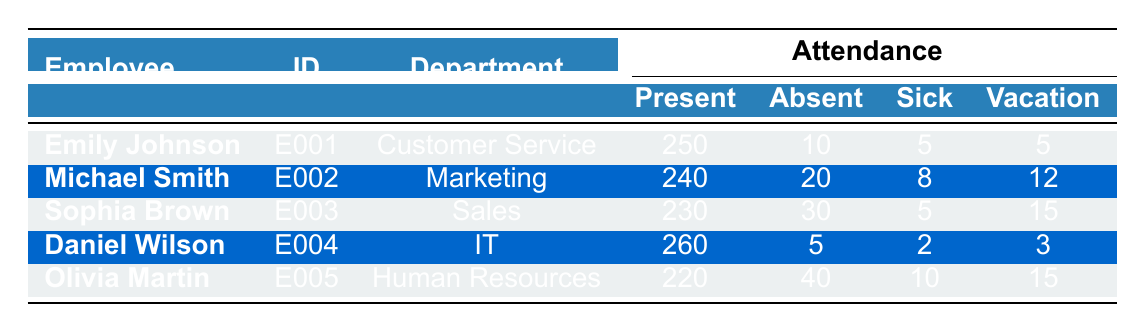What is the total number of sick leave days taken by all employees? To find the total sick leave days, we need to sum the sick leave days for each employee: 5 (Emily) + 8 (Michael) + 5 (Sophia) + 2 (Daniel) + 10 (Olivia) = 30.
Answer: 30 Who has the highest number of days present? By checking the "Present" column, Daniel Wilson has the highest number of days present at 260.
Answer: Daniel Wilson How many days absent in total were recorded by all employees? We need to sum the "Absent" days for each employee: 10 (Emily) + 20 (Michael) + 30 (Sophia) + 5 (Daniel) + 40 (Olivia) = 105.
Answer: 105 Is it true that Sophia Brown took more vacation days than Michael Smith? Sophia took 15 vacation days while Michael took 12 vacation days. Since 15 > 12, the statement is true.
Answer: Yes What is the average attendance of employees in terms of days present? To find the average, we sum the days present: 250 + 240 + 230 + 260 + 220 = 1210. There are 5 employees, so the average is 1210 / 5 = 242.
Answer: 242 Which department had the lowest total attendance (days present) and what was the number? Reviewing the "Days Present" column shows that Human Resources (Olivia) had the lowest attendance with 220 days present.
Answer: Human Resources, 220 Did any employee take sick leave days equal to or greater than vacation days? We check each employee: Emily (5 sick, 5 vacation), Michael (8 sick, 12 vacation), Sophia (5 sick, 15 vacation), Daniel (2 sick, 3 vacation), Olivia (10 sick, 15 vacation). Emily is the only one with equal days (5 sick = 5 vacation), so yes.
Answer: Yes What is the difference in days present between Daniel Wilson and Olivia Martin? Daniel has 260 days present while Olivia has 220 days present. The difference is 260 - 220 = 40 days.
Answer: 40 